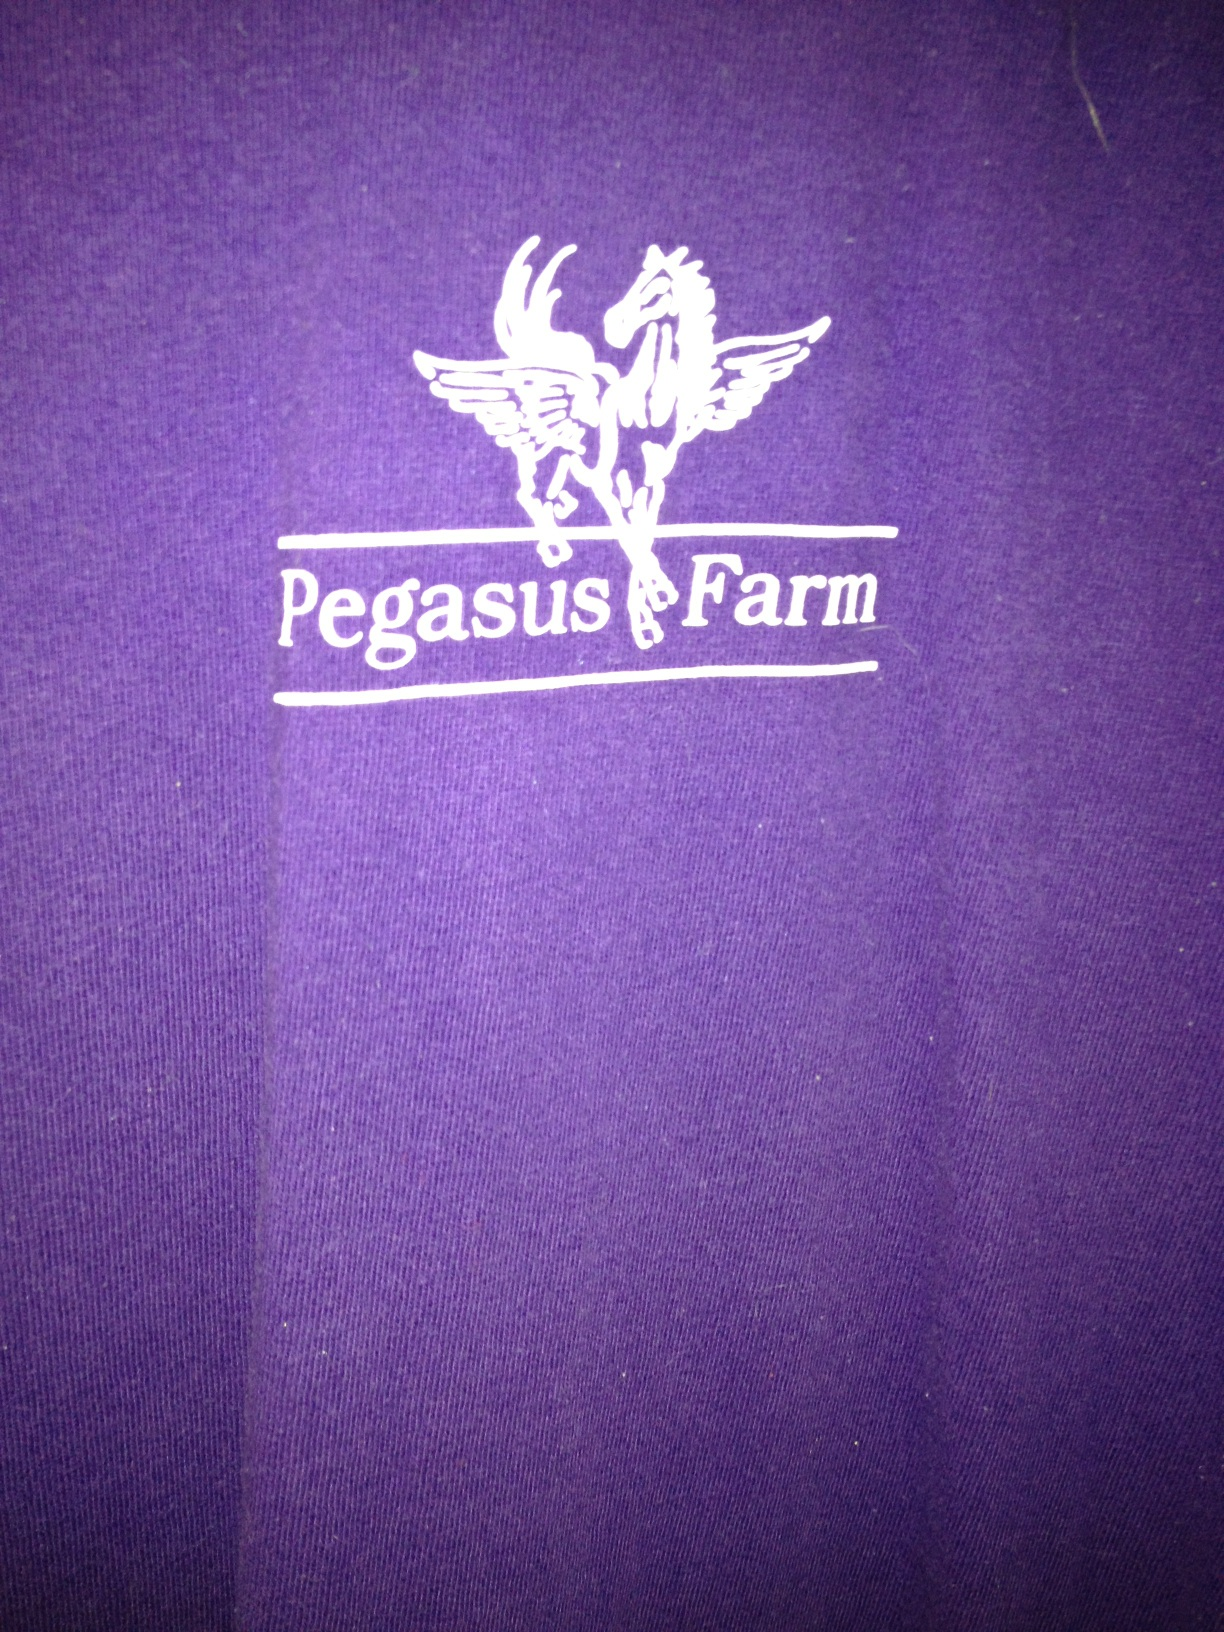What's the significance of the Pegasus on the shirt? The Pegasus is a mythical winged divine horse, and one of the most recognized creatures in Greek mythology. On your shirt, it likely symbolizes qualities like freedom, grace, and majesty, which might be emblematic of the values or spirit of the 'Pegasus Farm'. 